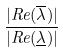<formula> <loc_0><loc_0><loc_500><loc_500>\frac { | R e ( \overline { \lambda } ) | } { | R e ( \underline { \lambda } ) | }</formula> 